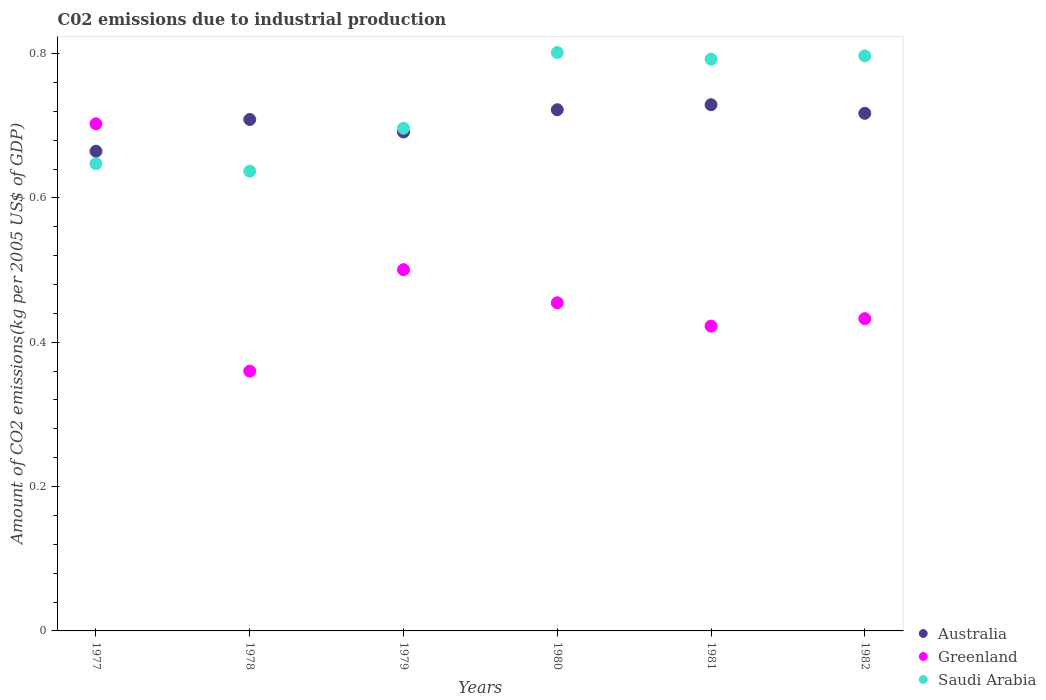Is the number of dotlines equal to the number of legend labels?
Provide a short and direct response. Yes. What is the amount of CO2 emitted due to industrial production in Greenland in 1978?
Give a very brief answer. 0.36. Across all years, what is the maximum amount of CO2 emitted due to industrial production in Greenland?
Your response must be concise. 0.7. Across all years, what is the minimum amount of CO2 emitted due to industrial production in Australia?
Provide a short and direct response. 0.66. In which year was the amount of CO2 emitted due to industrial production in Australia maximum?
Keep it short and to the point. 1981. What is the total amount of CO2 emitted due to industrial production in Australia in the graph?
Offer a terse response. 4.23. What is the difference between the amount of CO2 emitted due to industrial production in Greenland in 1979 and that in 1981?
Make the answer very short. 0.08. What is the difference between the amount of CO2 emitted due to industrial production in Saudi Arabia in 1981 and the amount of CO2 emitted due to industrial production in Greenland in 1977?
Your response must be concise. 0.09. What is the average amount of CO2 emitted due to industrial production in Saudi Arabia per year?
Your response must be concise. 0.73. In the year 1977, what is the difference between the amount of CO2 emitted due to industrial production in Saudi Arabia and amount of CO2 emitted due to industrial production in Australia?
Your answer should be compact. -0.02. What is the ratio of the amount of CO2 emitted due to industrial production in Australia in 1980 to that in 1982?
Make the answer very short. 1.01. Is the difference between the amount of CO2 emitted due to industrial production in Saudi Arabia in 1981 and 1982 greater than the difference between the amount of CO2 emitted due to industrial production in Australia in 1981 and 1982?
Provide a succinct answer. No. What is the difference between the highest and the second highest amount of CO2 emitted due to industrial production in Greenland?
Your response must be concise. 0.2. What is the difference between the highest and the lowest amount of CO2 emitted due to industrial production in Saudi Arabia?
Offer a very short reply. 0.16. In how many years, is the amount of CO2 emitted due to industrial production in Australia greater than the average amount of CO2 emitted due to industrial production in Australia taken over all years?
Make the answer very short. 4. How many years are there in the graph?
Offer a terse response. 6. What is the difference between two consecutive major ticks on the Y-axis?
Offer a very short reply. 0.2. Are the values on the major ticks of Y-axis written in scientific E-notation?
Provide a short and direct response. No. Does the graph contain grids?
Ensure brevity in your answer.  No. Where does the legend appear in the graph?
Provide a succinct answer. Bottom right. How many legend labels are there?
Give a very brief answer. 3. What is the title of the graph?
Give a very brief answer. C02 emissions due to industrial production. What is the label or title of the Y-axis?
Ensure brevity in your answer.  Amount of CO2 emissions(kg per 2005 US$ of GDP). What is the Amount of CO2 emissions(kg per 2005 US$ of GDP) of Australia in 1977?
Give a very brief answer. 0.66. What is the Amount of CO2 emissions(kg per 2005 US$ of GDP) in Greenland in 1977?
Offer a terse response. 0.7. What is the Amount of CO2 emissions(kg per 2005 US$ of GDP) of Saudi Arabia in 1977?
Keep it short and to the point. 0.65. What is the Amount of CO2 emissions(kg per 2005 US$ of GDP) of Australia in 1978?
Give a very brief answer. 0.71. What is the Amount of CO2 emissions(kg per 2005 US$ of GDP) in Greenland in 1978?
Offer a terse response. 0.36. What is the Amount of CO2 emissions(kg per 2005 US$ of GDP) in Saudi Arabia in 1978?
Ensure brevity in your answer.  0.64. What is the Amount of CO2 emissions(kg per 2005 US$ of GDP) of Australia in 1979?
Provide a short and direct response. 0.69. What is the Amount of CO2 emissions(kg per 2005 US$ of GDP) in Greenland in 1979?
Ensure brevity in your answer.  0.5. What is the Amount of CO2 emissions(kg per 2005 US$ of GDP) in Saudi Arabia in 1979?
Give a very brief answer. 0.7. What is the Amount of CO2 emissions(kg per 2005 US$ of GDP) of Australia in 1980?
Offer a terse response. 0.72. What is the Amount of CO2 emissions(kg per 2005 US$ of GDP) of Greenland in 1980?
Provide a succinct answer. 0.45. What is the Amount of CO2 emissions(kg per 2005 US$ of GDP) in Saudi Arabia in 1980?
Make the answer very short. 0.8. What is the Amount of CO2 emissions(kg per 2005 US$ of GDP) in Australia in 1981?
Ensure brevity in your answer.  0.73. What is the Amount of CO2 emissions(kg per 2005 US$ of GDP) of Greenland in 1981?
Give a very brief answer. 0.42. What is the Amount of CO2 emissions(kg per 2005 US$ of GDP) of Saudi Arabia in 1981?
Your answer should be compact. 0.79. What is the Amount of CO2 emissions(kg per 2005 US$ of GDP) of Australia in 1982?
Offer a terse response. 0.72. What is the Amount of CO2 emissions(kg per 2005 US$ of GDP) of Greenland in 1982?
Make the answer very short. 0.43. What is the Amount of CO2 emissions(kg per 2005 US$ of GDP) in Saudi Arabia in 1982?
Provide a succinct answer. 0.8. Across all years, what is the maximum Amount of CO2 emissions(kg per 2005 US$ of GDP) in Australia?
Offer a terse response. 0.73. Across all years, what is the maximum Amount of CO2 emissions(kg per 2005 US$ of GDP) in Greenland?
Offer a very short reply. 0.7. Across all years, what is the maximum Amount of CO2 emissions(kg per 2005 US$ of GDP) in Saudi Arabia?
Provide a succinct answer. 0.8. Across all years, what is the minimum Amount of CO2 emissions(kg per 2005 US$ of GDP) in Australia?
Make the answer very short. 0.66. Across all years, what is the minimum Amount of CO2 emissions(kg per 2005 US$ of GDP) of Greenland?
Your response must be concise. 0.36. Across all years, what is the minimum Amount of CO2 emissions(kg per 2005 US$ of GDP) of Saudi Arabia?
Your answer should be compact. 0.64. What is the total Amount of CO2 emissions(kg per 2005 US$ of GDP) of Australia in the graph?
Your response must be concise. 4.23. What is the total Amount of CO2 emissions(kg per 2005 US$ of GDP) of Greenland in the graph?
Make the answer very short. 2.87. What is the total Amount of CO2 emissions(kg per 2005 US$ of GDP) in Saudi Arabia in the graph?
Your response must be concise. 4.37. What is the difference between the Amount of CO2 emissions(kg per 2005 US$ of GDP) in Australia in 1977 and that in 1978?
Offer a very short reply. -0.04. What is the difference between the Amount of CO2 emissions(kg per 2005 US$ of GDP) in Greenland in 1977 and that in 1978?
Offer a terse response. 0.34. What is the difference between the Amount of CO2 emissions(kg per 2005 US$ of GDP) of Saudi Arabia in 1977 and that in 1978?
Your answer should be compact. 0.01. What is the difference between the Amount of CO2 emissions(kg per 2005 US$ of GDP) in Australia in 1977 and that in 1979?
Ensure brevity in your answer.  -0.03. What is the difference between the Amount of CO2 emissions(kg per 2005 US$ of GDP) of Greenland in 1977 and that in 1979?
Keep it short and to the point. 0.2. What is the difference between the Amount of CO2 emissions(kg per 2005 US$ of GDP) in Saudi Arabia in 1977 and that in 1979?
Your response must be concise. -0.05. What is the difference between the Amount of CO2 emissions(kg per 2005 US$ of GDP) of Australia in 1977 and that in 1980?
Your answer should be very brief. -0.06. What is the difference between the Amount of CO2 emissions(kg per 2005 US$ of GDP) of Greenland in 1977 and that in 1980?
Your answer should be compact. 0.25. What is the difference between the Amount of CO2 emissions(kg per 2005 US$ of GDP) of Saudi Arabia in 1977 and that in 1980?
Your response must be concise. -0.15. What is the difference between the Amount of CO2 emissions(kg per 2005 US$ of GDP) in Australia in 1977 and that in 1981?
Keep it short and to the point. -0.06. What is the difference between the Amount of CO2 emissions(kg per 2005 US$ of GDP) of Greenland in 1977 and that in 1981?
Provide a succinct answer. 0.28. What is the difference between the Amount of CO2 emissions(kg per 2005 US$ of GDP) of Saudi Arabia in 1977 and that in 1981?
Your response must be concise. -0.14. What is the difference between the Amount of CO2 emissions(kg per 2005 US$ of GDP) of Australia in 1977 and that in 1982?
Make the answer very short. -0.05. What is the difference between the Amount of CO2 emissions(kg per 2005 US$ of GDP) in Greenland in 1977 and that in 1982?
Make the answer very short. 0.27. What is the difference between the Amount of CO2 emissions(kg per 2005 US$ of GDP) of Saudi Arabia in 1977 and that in 1982?
Your answer should be compact. -0.15. What is the difference between the Amount of CO2 emissions(kg per 2005 US$ of GDP) in Australia in 1978 and that in 1979?
Your response must be concise. 0.02. What is the difference between the Amount of CO2 emissions(kg per 2005 US$ of GDP) in Greenland in 1978 and that in 1979?
Your answer should be compact. -0.14. What is the difference between the Amount of CO2 emissions(kg per 2005 US$ of GDP) of Saudi Arabia in 1978 and that in 1979?
Provide a short and direct response. -0.06. What is the difference between the Amount of CO2 emissions(kg per 2005 US$ of GDP) of Australia in 1978 and that in 1980?
Keep it short and to the point. -0.01. What is the difference between the Amount of CO2 emissions(kg per 2005 US$ of GDP) of Greenland in 1978 and that in 1980?
Make the answer very short. -0.09. What is the difference between the Amount of CO2 emissions(kg per 2005 US$ of GDP) in Saudi Arabia in 1978 and that in 1980?
Offer a very short reply. -0.16. What is the difference between the Amount of CO2 emissions(kg per 2005 US$ of GDP) of Australia in 1978 and that in 1981?
Offer a very short reply. -0.02. What is the difference between the Amount of CO2 emissions(kg per 2005 US$ of GDP) in Greenland in 1978 and that in 1981?
Provide a succinct answer. -0.06. What is the difference between the Amount of CO2 emissions(kg per 2005 US$ of GDP) in Saudi Arabia in 1978 and that in 1981?
Your response must be concise. -0.16. What is the difference between the Amount of CO2 emissions(kg per 2005 US$ of GDP) of Australia in 1978 and that in 1982?
Provide a short and direct response. -0.01. What is the difference between the Amount of CO2 emissions(kg per 2005 US$ of GDP) in Greenland in 1978 and that in 1982?
Provide a succinct answer. -0.07. What is the difference between the Amount of CO2 emissions(kg per 2005 US$ of GDP) of Saudi Arabia in 1978 and that in 1982?
Provide a short and direct response. -0.16. What is the difference between the Amount of CO2 emissions(kg per 2005 US$ of GDP) of Australia in 1979 and that in 1980?
Give a very brief answer. -0.03. What is the difference between the Amount of CO2 emissions(kg per 2005 US$ of GDP) in Greenland in 1979 and that in 1980?
Your answer should be compact. 0.05. What is the difference between the Amount of CO2 emissions(kg per 2005 US$ of GDP) in Saudi Arabia in 1979 and that in 1980?
Keep it short and to the point. -0.1. What is the difference between the Amount of CO2 emissions(kg per 2005 US$ of GDP) in Australia in 1979 and that in 1981?
Offer a very short reply. -0.04. What is the difference between the Amount of CO2 emissions(kg per 2005 US$ of GDP) in Greenland in 1979 and that in 1981?
Provide a succinct answer. 0.08. What is the difference between the Amount of CO2 emissions(kg per 2005 US$ of GDP) in Saudi Arabia in 1979 and that in 1981?
Offer a very short reply. -0.1. What is the difference between the Amount of CO2 emissions(kg per 2005 US$ of GDP) in Australia in 1979 and that in 1982?
Keep it short and to the point. -0.03. What is the difference between the Amount of CO2 emissions(kg per 2005 US$ of GDP) in Greenland in 1979 and that in 1982?
Provide a short and direct response. 0.07. What is the difference between the Amount of CO2 emissions(kg per 2005 US$ of GDP) in Saudi Arabia in 1979 and that in 1982?
Offer a very short reply. -0.1. What is the difference between the Amount of CO2 emissions(kg per 2005 US$ of GDP) in Australia in 1980 and that in 1981?
Keep it short and to the point. -0.01. What is the difference between the Amount of CO2 emissions(kg per 2005 US$ of GDP) of Greenland in 1980 and that in 1981?
Give a very brief answer. 0.03. What is the difference between the Amount of CO2 emissions(kg per 2005 US$ of GDP) of Saudi Arabia in 1980 and that in 1981?
Provide a succinct answer. 0.01. What is the difference between the Amount of CO2 emissions(kg per 2005 US$ of GDP) of Australia in 1980 and that in 1982?
Offer a very short reply. 0.01. What is the difference between the Amount of CO2 emissions(kg per 2005 US$ of GDP) in Greenland in 1980 and that in 1982?
Offer a very short reply. 0.02. What is the difference between the Amount of CO2 emissions(kg per 2005 US$ of GDP) of Saudi Arabia in 1980 and that in 1982?
Offer a very short reply. 0. What is the difference between the Amount of CO2 emissions(kg per 2005 US$ of GDP) in Australia in 1981 and that in 1982?
Keep it short and to the point. 0.01. What is the difference between the Amount of CO2 emissions(kg per 2005 US$ of GDP) in Greenland in 1981 and that in 1982?
Give a very brief answer. -0.01. What is the difference between the Amount of CO2 emissions(kg per 2005 US$ of GDP) of Saudi Arabia in 1981 and that in 1982?
Your response must be concise. -0. What is the difference between the Amount of CO2 emissions(kg per 2005 US$ of GDP) of Australia in 1977 and the Amount of CO2 emissions(kg per 2005 US$ of GDP) of Greenland in 1978?
Offer a terse response. 0.3. What is the difference between the Amount of CO2 emissions(kg per 2005 US$ of GDP) in Australia in 1977 and the Amount of CO2 emissions(kg per 2005 US$ of GDP) in Saudi Arabia in 1978?
Ensure brevity in your answer.  0.03. What is the difference between the Amount of CO2 emissions(kg per 2005 US$ of GDP) in Greenland in 1977 and the Amount of CO2 emissions(kg per 2005 US$ of GDP) in Saudi Arabia in 1978?
Your answer should be very brief. 0.07. What is the difference between the Amount of CO2 emissions(kg per 2005 US$ of GDP) of Australia in 1977 and the Amount of CO2 emissions(kg per 2005 US$ of GDP) of Greenland in 1979?
Provide a short and direct response. 0.16. What is the difference between the Amount of CO2 emissions(kg per 2005 US$ of GDP) in Australia in 1977 and the Amount of CO2 emissions(kg per 2005 US$ of GDP) in Saudi Arabia in 1979?
Make the answer very short. -0.03. What is the difference between the Amount of CO2 emissions(kg per 2005 US$ of GDP) of Greenland in 1977 and the Amount of CO2 emissions(kg per 2005 US$ of GDP) of Saudi Arabia in 1979?
Your answer should be very brief. 0.01. What is the difference between the Amount of CO2 emissions(kg per 2005 US$ of GDP) in Australia in 1977 and the Amount of CO2 emissions(kg per 2005 US$ of GDP) in Greenland in 1980?
Your response must be concise. 0.21. What is the difference between the Amount of CO2 emissions(kg per 2005 US$ of GDP) in Australia in 1977 and the Amount of CO2 emissions(kg per 2005 US$ of GDP) in Saudi Arabia in 1980?
Offer a terse response. -0.14. What is the difference between the Amount of CO2 emissions(kg per 2005 US$ of GDP) in Greenland in 1977 and the Amount of CO2 emissions(kg per 2005 US$ of GDP) in Saudi Arabia in 1980?
Keep it short and to the point. -0.1. What is the difference between the Amount of CO2 emissions(kg per 2005 US$ of GDP) in Australia in 1977 and the Amount of CO2 emissions(kg per 2005 US$ of GDP) in Greenland in 1981?
Your answer should be compact. 0.24. What is the difference between the Amount of CO2 emissions(kg per 2005 US$ of GDP) of Australia in 1977 and the Amount of CO2 emissions(kg per 2005 US$ of GDP) of Saudi Arabia in 1981?
Provide a succinct answer. -0.13. What is the difference between the Amount of CO2 emissions(kg per 2005 US$ of GDP) of Greenland in 1977 and the Amount of CO2 emissions(kg per 2005 US$ of GDP) of Saudi Arabia in 1981?
Keep it short and to the point. -0.09. What is the difference between the Amount of CO2 emissions(kg per 2005 US$ of GDP) of Australia in 1977 and the Amount of CO2 emissions(kg per 2005 US$ of GDP) of Greenland in 1982?
Keep it short and to the point. 0.23. What is the difference between the Amount of CO2 emissions(kg per 2005 US$ of GDP) in Australia in 1977 and the Amount of CO2 emissions(kg per 2005 US$ of GDP) in Saudi Arabia in 1982?
Provide a succinct answer. -0.13. What is the difference between the Amount of CO2 emissions(kg per 2005 US$ of GDP) in Greenland in 1977 and the Amount of CO2 emissions(kg per 2005 US$ of GDP) in Saudi Arabia in 1982?
Make the answer very short. -0.09. What is the difference between the Amount of CO2 emissions(kg per 2005 US$ of GDP) in Australia in 1978 and the Amount of CO2 emissions(kg per 2005 US$ of GDP) in Greenland in 1979?
Your answer should be very brief. 0.21. What is the difference between the Amount of CO2 emissions(kg per 2005 US$ of GDP) of Australia in 1978 and the Amount of CO2 emissions(kg per 2005 US$ of GDP) of Saudi Arabia in 1979?
Keep it short and to the point. 0.01. What is the difference between the Amount of CO2 emissions(kg per 2005 US$ of GDP) in Greenland in 1978 and the Amount of CO2 emissions(kg per 2005 US$ of GDP) in Saudi Arabia in 1979?
Offer a terse response. -0.34. What is the difference between the Amount of CO2 emissions(kg per 2005 US$ of GDP) in Australia in 1978 and the Amount of CO2 emissions(kg per 2005 US$ of GDP) in Greenland in 1980?
Ensure brevity in your answer.  0.25. What is the difference between the Amount of CO2 emissions(kg per 2005 US$ of GDP) in Australia in 1978 and the Amount of CO2 emissions(kg per 2005 US$ of GDP) in Saudi Arabia in 1980?
Ensure brevity in your answer.  -0.09. What is the difference between the Amount of CO2 emissions(kg per 2005 US$ of GDP) in Greenland in 1978 and the Amount of CO2 emissions(kg per 2005 US$ of GDP) in Saudi Arabia in 1980?
Your answer should be compact. -0.44. What is the difference between the Amount of CO2 emissions(kg per 2005 US$ of GDP) of Australia in 1978 and the Amount of CO2 emissions(kg per 2005 US$ of GDP) of Greenland in 1981?
Provide a short and direct response. 0.29. What is the difference between the Amount of CO2 emissions(kg per 2005 US$ of GDP) in Australia in 1978 and the Amount of CO2 emissions(kg per 2005 US$ of GDP) in Saudi Arabia in 1981?
Ensure brevity in your answer.  -0.08. What is the difference between the Amount of CO2 emissions(kg per 2005 US$ of GDP) in Greenland in 1978 and the Amount of CO2 emissions(kg per 2005 US$ of GDP) in Saudi Arabia in 1981?
Provide a short and direct response. -0.43. What is the difference between the Amount of CO2 emissions(kg per 2005 US$ of GDP) in Australia in 1978 and the Amount of CO2 emissions(kg per 2005 US$ of GDP) in Greenland in 1982?
Provide a succinct answer. 0.28. What is the difference between the Amount of CO2 emissions(kg per 2005 US$ of GDP) of Australia in 1978 and the Amount of CO2 emissions(kg per 2005 US$ of GDP) of Saudi Arabia in 1982?
Give a very brief answer. -0.09. What is the difference between the Amount of CO2 emissions(kg per 2005 US$ of GDP) in Greenland in 1978 and the Amount of CO2 emissions(kg per 2005 US$ of GDP) in Saudi Arabia in 1982?
Make the answer very short. -0.44. What is the difference between the Amount of CO2 emissions(kg per 2005 US$ of GDP) in Australia in 1979 and the Amount of CO2 emissions(kg per 2005 US$ of GDP) in Greenland in 1980?
Your answer should be compact. 0.24. What is the difference between the Amount of CO2 emissions(kg per 2005 US$ of GDP) of Australia in 1979 and the Amount of CO2 emissions(kg per 2005 US$ of GDP) of Saudi Arabia in 1980?
Make the answer very short. -0.11. What is the difference between the Amount of CO2 emissions(kg per 2005 US$ of GDP) in Greenland in 1979 and the Amount of CO2 emissions(kg per 2005 US$ of GDP) in Saudi Arabia in 1980?
Your answer should be very brief. -0.3. What is the difference between the Amount of CO2 emissions(kg per 2005 US$ of GDP) of Australia in 1979 and the Amount of CO2 emissions(kg per 2005 US$ of GDP) of Greenland in 1981?
Give a very brief answer. 0.27. What is the difference between the Amount of CO2 emissions(kg per 2005 US$ of GDP) of Australia in 1979 and the Amount of CO2 emissions(kg per 2005 US$ of GDP) of Saudi Arabia in 1981?
Provide a succinct answer. -0.1. What is the difference between the Amount of CO2 emissions(kg per 2005 US$ of GDP) in Greenland in 1979 and the Amount of CO2 emissions(kg per 2005 US$ of GDP) in Saudi Arabia in 1981?
Your response must be concise. -0.29. What is the difference between the Amount of CO2 emissions(kg per 2005 US$ of GDP) of Australia in 1979 and the Amount of CO2 emissions(kg per 2005 US$ of GDP) of Greenland in 1982?
Offer a very short reply. 0.26. What is the difference between the Amount of CO2 emissions(kg per 2005 US$ of GDP) of Australia in 1979 and the Amount of CO2 emissions(kg per 2005 US$ of GDP) of Saudi Arabia in 1982?
Your response must be concise. -0.11. What is the difference between the Amount of CO2 emissions(kg per 2005 US$ of GDP) of Greenland in 1979 and the Amount of CO2 emissions(kg per 2005 US$ of GDP) of Saudi Arabia in 1982?
Your response must be concise. -0.3. What is the difference between the Amount of CO2 emissions(kg per 2005 US$ of GDP) in Australia in 1980 and the Amount of CO2 emissions(kg per 2005 US$ of GDP) in Greenland in 1981?
Your answer should be compact. 0.3. What is the difference between the Amount of CO2 emissions(kg per 2005 US$ of GDP) in Australia in 1980 and the Amount of CO2 emissions(kg per 2005 US$ of GDP) in Saudi Arabia in 1981?
Provide a short and direct response. -0.07. What is the difference between the Amount of CO2 emissions(kg per 2005 US$ of GDP) in Greenland in 1980 and the Amount of CO2 emissions(kg per 2005 US$ of GDP) in Saudi Arabia in 1981?
Ensure brevity in your answer.  -0.34. What is the difference between the Amount of CO2 emissions(kg per 2005 US$ of GDP) in Australia in 1980 and the Amount of CO2 emissions(kg per 2005 US$ of GDP) in Greenland in 1982?
Offer a very short reply. 0.29. What is the difference between the Amount of CO2 emissions(kg per 2005 US$ of GDP) in Australia in 1980 and the Amount of CO2 emissions(kg per 2005 US$ of GDP) in Saudi Arabia in 1982?
Your response must be concise. -0.07. What is the difference between the Amount of CO2 emissions(kg per 2005 US$ of GDP) of Greenland in 1980 and the Amount of CO2 emissions(kg per 2005 US$ of GDP) of Saudi Arabia in 1982?
Provide a short and direct response. -0.34. What is the difference between the Amount of CO2 emissions(kg per 2005 US$ of GDP) of Australia in 1981 and the Amount of CO2 emissions(kg per 2005 US$ of GDP) of Greenland in 1982?
Offer a terse response. 0.3. What is the difference between the Amount of CO2 emissions(kg per 2005 US$ of GDP) in Australia in 1981 and the Amount of CO2 emissions(kg per 2005 US$ of GDP) in Saudi Arabia in 1982?
Make the answer very short. -0.07. What is the difference between the Amount of CO2 emissions(kg per 2005 US$ of GDP) in Greenland in 1981 and the Amount of CO2 emissions(kg per 2005 US$ of GDP) in Saudi Arabia in 1982?
Ensure brevity in your answer.  -0.37. What is the average Amount of CO2 emissions(kg per 2005 US$ of GDP) of Australia per year?
Your answer should be compact. 0.71. What is the average Amount of CO2 emissions(kg per 2005 US$ of GDP) in Greenland per year?
Make the answer very short. 0.48. What is the average Amount of CO2 emissions(kg per 2005 US$ of GDP) of Saudi Arabia per year?
Your answer should be very brief. 0.73. In the year 1977, what is the difference between the Amount of CO2 emissions(kg per 2005 US$ of GDP) of Australia and Amount of CO2 emissions(kg per 2005 US$ of GDP) of Greenland?
Your answer should be compact. -0.04. In the year 1977, what is the difference between the Amount of CO2 emissions(kg per 2005 US$ of GDP) in Australia and Amount of CO2 emissions(kg per 2005 US$ of GDP) in Saudi Arabia?
Give a very brief answer. 0.02. In the year 1977, what is the difference between the Amount of CO2 emissions(kg per 2005 US$ of GDP) in Greenland and Amount of CO2 emissions(kg per 2005 US$ of GDP) in Saudi Arabia?
Make the answer very short. 0.06. In the year 1978, what is the difference between the Amount of CO2 emissions(kg per 2005 US$ of GDP) in Australia and Amount of CO2 emissions(kg per 2005 US$ of GDP) in Greenland?
Your answer should be very brief. 0.35. In the year 1978, what is the difference between the Amount of CO2 emissions(kg per 2005 US$ of GDP) in Australia and Amount of CO2 emissions(kg per 2005 US$ of GDP) in Saudi Arabia?
Offer a very short reply. 0.07. In the year 1978, what is the difference between the Amount of CO2 emissions(kg per 2005 US$ of GDP) of Greenland and Amount of CO2 emissions(kg per 2005 US$ of GDP) of Saudi Arabia?
Your response must be concise. -0.28. In the year 1979, what is the difference between the Amount of CO2 emissions(kg per 2005 US$ of GDP) in Australia and Amount of CO2 emissions(kg per 2005 US$ of GDP) in Greenland?
Offer a very short reply. 0.19. In the year 1979, what is the difference between the Amount of CO2 emissions(kg per 2005 US$ of GDP) in Australia and Amount of CO2 emissions(kg per 2005 US$ of GDP) in Saudi Arabia?
Make the answer very short. -0.01. In the year 1979, what is the difference between the Amount of CO2 emissions(kg per 2005 US$ of GDP) in Greenland and Amount of CO2 emissions(kg per 2005 US$ of GDP) in Saudi Arabia?
Keep it short and to the point. -0.2. In the year 1980, what is the difference between the Amount of CO2 emissions(kg per 2005 US$ of GDP) of Australia and Amount of CO2 emissions(kg per 2005 US$ of GDP) of Greenland?
Your answer should be very brief. 0.27. In the year 1980, what is the difference between the Amount of CO2 emissions(kg per 2005 US$ of GDP) in Australia and Amount of CO2 emissions(kg per 2005 US$ of GDP) in Saudi Arabia?
Keep it short and to the point. -0.08. In the year 1980, what is the difference between the Amount of CO2 emissions(kg per 2005 US$ of GDP) in Greenland and Amount of CO2 emissions(kg per 2005 US$ of GDP) in Saudi Arabia?
Your answer should be very brief. -0.35. In the year 1981, what is the difference between the Amount of CO2 emissions(kg per 2005 US$ of GDP) in Australia and Amount of CO2 emissions(kg per 2005 US$ of GDP) in Greenland?
Provide a short and direct response. 0.31. In the year 1981, what is the difference between the Amount of CO2 emissions(kg per 2005 US$ of GDP) in Australia and Amount of CO2 emissions(kg per 2005 US$ of GDP) in Saudi Arabia?
Make the answer very short. -0.06. In the year 1981, what is the difference between the Amount of CO2 emissions(kg per 2005 US$ of GDP) of Greenland and Amount of CO2 emissions(kg per 2005 US$ of GDP) of Saudi Arabia?
Your answer should be compact. -0.37. In the year 1982, what is the difference between the Amount of CO2 emissions(kg per 2005 US$ of GDP) in Australia and Amount of CO2 emissions(kg per 2005 US$ of GDP) in Greenland?
Your response must be concise. 0.28. In the year 1982, what is the difference between the Amount of CO2 emissions(kg per 2005 US$ of GDP) of Australia and Amount of CO2 emissions(kg per 2005 US$ of GDP) of Saudi Arabia?
Ensure brevity in your answer.  -0.08. In the year 1982, what is the difference between the Amount of CO2 emissions(kg per 2005 US$ of GDP) in Greenland and Amount of CO2 emissions(kg per 2005 US$ of GDP) in Saudi Arabia?
Your response must be concise. -0.36. What is the ratio of the Amount of CO2 emissions(kg per 2005 US$ of GDP) in Australia in 1977 to that in 1978?
Ensure brevity in your answer.  0.94. What is the ratio of the Amount of CO2 emissions(kg per 2005 US$ of GDP) of Greenland in 1977 to that in 1978?
Keep it short and to the point. 1.95. What is the ratio of the Amount of CO2 emissions(kg per 2005 US$ of GDP) in Saudi Arabia in 1977 to that in 1978?
Offer a very short reply. 1.02. What is the ratio of the Amount of CO2 emissions(kg per 2005 US$ of GDP) of Australia in 1977 to that in 1979?
Provide a succinct answer. 0.96. What is the ratio of the Amount of CO2 emissions(kg per 2005 US$ of GDP) of Greenland in 1977 to that in 1979?
Make the answer very short. 1.4. What is the ratio of the Amount of CO2 emissions(kg per 2005 US$ of GDP) in Saudi Arabia in 1977 to that in 1979?
Your answer should be compact. 0.93. What is the ratio of the Amount of CO2 emissions(kg per 2005 US$ of GDP) in Australia in 1977 to that in 1980?
Your answer should be compact. 0.92. What is the ratio of the Amount of CO2 emissions(kg per 2005 US$ of GDP) in Greenland in 1977 to that in 1980?
Provide a succinct answer. 1.55. What is the ratio of the Amount of CO2 emissions(kg per 2005 US$ of GDP) in Saudi Arabia in 1977 to that in 1980?
Offer a very short reply. 0.81. What is the ratio of the Amount of CO2 emissions(kg per 2005 US$ of GDP) of Australia in 1977 to that in 1981?
Offer a very short reply. 0.91. What is the ratio of the Amount of CO2 emissions(kg per 2005 US$ of GDP) of Greenland in 1977 to that in 1981?
Provide a short and direct response. 1.66. What is the ratio of the Amount of CO2 emissions(kg per 2005 US$ of GDP) in Saudi Arabia in 1977 to that in 1981?
Your response must be concise. 0.82. What is the ratio of the Amount of CO2 emissions(kg per 2005 US$ of GDP) in Australia in 1977 to that in 1982?
Ensure brevity in your answer.  0.93. What is the ratio of the Amount of CO2 emissions(kg per 2005 US$ of GDP) of Greenland in 1977 to that in 1982?
Your answer should be compact. 1.62. What is the ratio of the Amount of CO2 emissions(kg per 2005 US$ of GDP) of Saudi Arabia in 1977 to that in 1982?
Your answer should be very brief. 0.81. What is the ratio of the Amount of CO2 emissions(kg per 2005 US$ of GDP) of Australia in 1978 to that in 1979?
Your answer should be compact. 1.02. What is the ratio of the Amount of CO2 emissions(kg per 2005 US$ of GDP) of Greenland in 1978 to that in 1979?
Ensure brevity in your answer.  0.72. What is the ratio of the Amount of CO2 emissions(kg per 2005 US$ of GDP) in Saudi Arabia in 1978 to that in 1979?
Make the answer very short. 0.91. What is the ratio of the Amount of CO2 emissions(kg per 2005 US$ of GDP) of Australia in 1978 to that in 1980?
Provide a short and direct response. 0.98. What is the ratio of the Amount of CO2 emissions(kg per 2005 US$ of GDP) of Greenland in 1978 to that in 1980?
Make the answer very short. 0.79. What is the ratio of the Amount of CO2 emissions(kg per 2005 US$ of GDP) in Saudi Arabia in 1978 to that in 1980?
Your response must be concise. 0.79. What is the ratio of the Amount of CO2 emissions(kg per 2005 US$ of GDP) in Australia in 1978 to that in 1981?
Your response must be concise. 0.97. What is the ratio of the Amount of CO2 emissions(kg per 2005 US$ of GDP) in Greenland in 1978 to that in 1981?
Keep it short and to the point. 0.85. What is the ratio of the Amount of CO2 emissions(kg per 2005 US$ of GDP) in Saudi Arabia in 1978 to that in 1981?
Provide a succinct answer. 0.8. What is the ratio of the Amount of CO2 emissions(kg per 2005 US$ of GDP) of Greenland in 1978 to that in 1982?
Provide a succinct answer. 0.83. What is the ratio of the Amount of CO2 emissions(kg per 2005 US$ of GDP) of Saudi Arabia in 1978 to that in 1982?
Offer a very short reply. 0.8. What is the ratio of the Amount of CO2 emissions(kg per 2005 US$ of GDP) of Australia in 1979 to that in 1980?
Keep it short and to the point. 0.96. What is the ratio of the Amount of CO2 emissions(kg per 2005 US$ of GDP) in Greenland in 1979 to that in 1980?
Your answer should be very brief. 1.1. What is the ratio of the Amount of CO2 emissions(kg per 2005 US$ of GDP) of Saudi Arabia in 1979 to that in 1980?
Give a very brief answer. 0.87. What is the ratio of the Amount of CO2 emissions(kg per 2005 US$ of GDP) of Australia in 1979 to that in 1981?
Keep it short and to the point. 0.95. What is the ratio of the Amount of CO2 emissions(kg per 2005 US$ of GDP) of Greenland in 1979 to that in 1981?
Provide a succinct answer. 1.19. What is the ratio of the Amount of CO2 emissions(kg per 2005 US$ of GDP) in Saudi Arabia in 1979 to that in 1981?
Your answer should be compact. 0.88. What is the ratio of the Amount of CO2 emissions(kg per 2005 US$ of GDP) of Australia in 1979 to that in 1982?
Provide a short and direct response. 0.96. What is the ratio of the Amount of CO2 emissions(kg per 2005 US$ of GDP) in Greenland in 1979 to that in 1982?
Your response must be concise. 1.16. What is the ratio of the Amount of CO2 emissions(kg per 2005 US$ of GDP) of Saudi Arabia in 1979 to that in 1982?
Your answer should be very brief. 0.87. What is the ratio of the Amount of CO2 emissions(kg per 2005 US$ of GDP) in Australia in 1980 to that in 1981?
Your answer should be compact. 0.99. What is the ratio of the Amount of CO2 emissions(kg per 2005 US$ of GDP) of Greenland in 1980 to that in 1981?
Make the answer very short. 1.08. What is the ratio of the Amount of CO2 emissions(kg per 2005 US$ of GDP) in Saudi Arabia in 1980 to that in 1981?
Make the answer very short. 1.01. What is the ratio of the Amount of CO2 emissions(kg per 2005 US$ of GDP) in Australia in 1980 to that in 1982?
Your response must be concise. 1.01. What is the ratio of the Amount of CO2 emissions(kg per 2005 US$ of GDP) in Greenland in 1980 to that in 1982?
Offer a very short reply. 1.05. What is the ratio of the Amount of CO2 emissions(kg per 2005 US$ of GDP) in Saudi Arabia in 1980 to that in 1982?
Your answer should be compact. 1.01. What is the ratio of the Amount of CO2 emissions(kg per 2005 US$ of GDP) in Australia in 1981 to that in 1982?
Give a very brief answer. 1.02. What is the ratio of the Amount of CO2 emissions(kg per 2005 US$ of GDP) of Greenland in 1981 to that in 1982?
Ensure brevity in your answer.  0.98. What is the ratio of the Amount of CO2 emissions(kg per 2005 US$ of GDP) of Saudi Arabia in 1981 to that in 1982?
Your answer should be very brief. 0.99. What is the difference between the highest and the second highest Amount of CO2 emissions(kg per 2005 US$ of GDP) in Australia?
Keep it short and to the point. 0.01. What is the difference between the highest and the second highest Amount of CO2 emissions(kg per 2005 US$ of GDP) in Greenland?
Provide a short and direct response. 0.2. What is the difference between the highest and the second highest Amount of CO2 emissions(kg per 2005 US$ of GDP) in Saudi Arabia?
Ensure brevity in your answer.  0. What is the difference between the highest and the lowest Amount of CO2 emissions(kg per 2005 US$ of GDP) in Australia?
Your answer should be very brief. 0.06. What is the difference between the highest and the lowest Amount of CO2 emissions(kg per 2005 US$ of GDP) of Greenland?
Ensure brevity in your answer.  0.34. What is the difference between the highest and the lowest Amount of CO2 emissions(kg per 2005 US$ of GDP) in Saudi Arabia?
Provide a succinct answer. 0.16. 